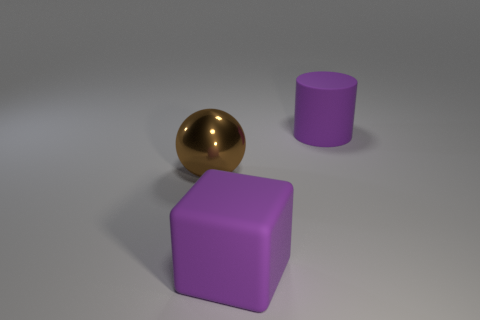Add 2 large purple cylinders. How many objects exist? 5 Subtract all cylinders. How many objects are left? 2 Add 1 small gray metallic balls. How many small gray metallic balls exist? 1 Subtract 0 blue cubes. How many objects are left? 3 Subtract all blocks. Subtract all big metallic cubes. How many objects are left? 2 Add 1 big spheres. How many big spheres are left? 2 